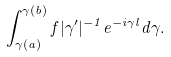<formula> <loc_0><loc_0><loc_500><loc_500>\int _ { \gamma ( a ) } ^ { \gamma ( b ) } f | \gamma ^ { \prime } | ^ { - 1 } e ^ { - i \gamma l } d \gamma .</formula> 